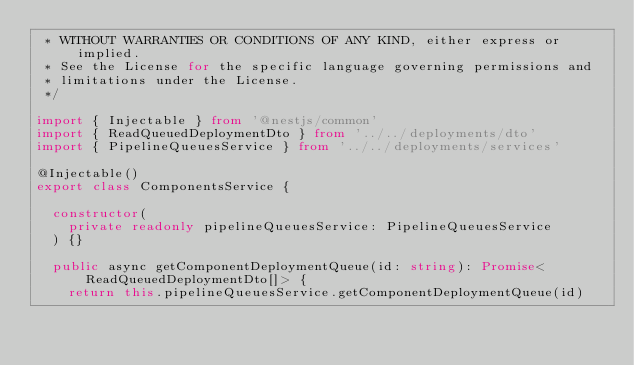Convert code to text. <code><loc_0><loc_0><loc_500><loc_500><_TypeScript_> * WITHOUT WARRANTIES OR CONDITIONS OF ANY KIND, either express or implied.
 * See the License for the specific language governing permissions and
 * limitations under the License.
 */

import { Injectable } from '@nestjs/common'
import { ReadQueuedDeploymentDto } from '../../deployments/dto'
import { PipelineQueuesService } from '../../deployments/services'

@Injectable()
export class ComponentsService {

  constructor(
    private readonly pipelineQueuesService: PipelineQueuesService
  ) {}

  public async getComponentDeploymentQueue(id: string): Promise<ReadQueuedDeploymentDto[]> {
    return this.pipelineQueuesService.getComponentDeploymentQueue(id)</code> 